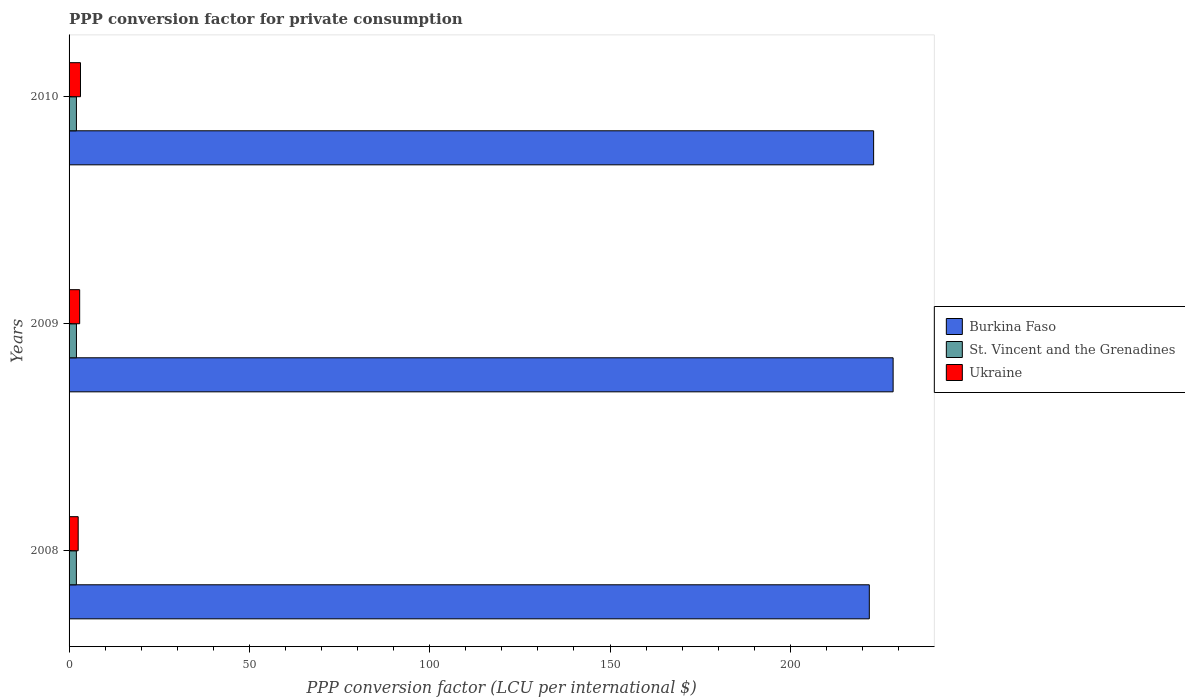How many different coloured bars are there?
Ensure brevity in your answer.  3. How many groups of bars are there?
Offer a terse response. 3. How many bars are there on the 3rd tick from the top?
Make the answer very short. 3. How many bars are there on the 2nd tick from the bottom?
Provide a succinct answer. 3. What is the PPP conversion factor for private consumption in St. Vincent and the Grenadines in 2009?
Offer a very short reply. 2.04. Across all years, what is the maximum PPP conversion factor for private consumption in St. Vincent and the Grenadines?
Give a very brief answer. 2.04. Across all years, what is the minimum PPP conversion factor for private consumption in Ukraine?
Your response must be concise. 2.53. What is the total PPP conversion factor for private consumption in St. Vincent and the Grenadines in the graph?
Your answer should be compact. 6.11. What is the difference between the PPP conversion factor for private consumption in St. Vincent and the Grenadines in 2008 and that in 2010?
Make the answer very short. -0.01. What is the difference between the PPP conversion factor for private consumption in Burkina Faso in 2009 and the PPP conversion factor for private consumption in St. Vincent and the Grenadines in 2008?
Provide a short and direct response. 226.48. What is the average PPP conversion factor for private consumption in St. Vincent and the Grenadines per year?
Keep it short and to the point. 2.04. In the year 2008, what is the difference between the PPP conversion factor for private consumption in St. Vincent and the Grenadines and PPP conversion factor for private consumption in Ukraine?
Give a very brief answer. -0.5. In how many years, is the PPP conversion factor for private consumption in St. Vincent and the Grenadines greater than 70 LCU?
Give a very brief answer. 0. What is the ratio of the PPP conversion factor for private consumption in Burkina Faso in 2008 to that in 2010?
Give a very brief answer. 0.99. Is the PPP conversion factor for private consumption in Burkina Faso in 2008 less than that in 2010?
Give a very brief answer. Yes. Is the difference between the PPP conversion factor for private consumption in St. Vincent and the Grenadines in 2008 and 2010 greater than the difference between the PPP conversion factor for private consumption in Ukraine in 2008 and 2010?
Offer a very short reply. Yes. What is the difference between the highest and the second highest PPP conversion factor for private consumption in St. Vincent and the Grenadines?
Make the answer very short. 0. What is the difference between the highest and the lowest PPP conversion factor for private consumption in Ukraine?
Your answer should be very brief. 0.64. In how many years, is the PPP conversion factor for private consumption in St. Vincent and the Grenadines greater than the average PPP conversion factor for private consumption in St. Vincent and the Grenadines taken over all years?
Your answer should be compact. 2. What does the 2nd bar from the top in 2010 represents?
Your response must be concise. St. Vincent and the Grenadines. What does the 3rd bar from the bottom in 2008 represents?
Your response must be concise. Ukraine. Are all the bars in the graph horizontal?
Offer a very short reply. Yes. How many years are there in the graph?
Your answer should be compact. 3. What is the difference between two consecutive major ticks on the X-axis?
Provide a succinct answer. 50. Does the graph contain any zero values?
Your answer should be very brief. No. Does the graph contain grids?
Offer a terse response. No. Where does the legend appear in the graph?
Your answer should be compact. Center right. What is the title of the graph?
Keep it short and to the point. PPP conversion factor for private consumption. What is the label or title of the X-axis?
Offer a terse response. PPP conversion factor (LCU per international $). What is the PPP conversion factor (LCU per international $) in Burkina Faso in 2008?
Ensure brevity in your answer.  221.91. What is the PPP conversion factor (LCU per international $) in St. Vincent and the Grenadines in 2008?
Ensure brevity in your answer.  2.03. What is the PPP conversion factor (LCU per international $) in Ukraine in 2008?
Offer a terse response. 2.53. What is the PPP conversion factor (LCU per international $) of Burkina Faso in 2009?
Give a very brief answer. 228.51. What is the PPP conversion factor (LCU per international $) in St. Vincent and the Grenadines in 2009?
Ensure brevity in your answer.  2.04. What is the PPP conversion factor (LCU per international $) in Ukraine in 2009?
Make the answer very short. 2.94. What is the PPP conversion factor (LCU per international $) in Burkina Faso in 2010?
Provide a succinct answer. 223.1. What is the PPP conversion factor (LCU per international $) in St. Vincent and the Grenadines in 2010?
Offer a terse response. 2.04. What is the PPP conversion factor (LCU per international $) in Ukraine in 2010?
Your response must be concise. 3.16. Across all years, what is the maximum PPP conversion factor (LCU per international $) of Burkina Faso?
Make the answer very short. 228.51. Across all years, what is the maximum PPP conversion factor (LCU per international $) of St. Vincent and the Grenadines?
Offer a very short reply. 2.04. Across all years, what is the maximum PPP conversion factor (LCU per international $) of Ukraine?
Your answer should be compact. 3.16. Across all years, what is the minimum PPP conversion factor (LCU per international $) of Burkina Faso?
Provide a succinct answer. 221.91. Across all years, what is the minimum PPP conversion factor (LCU per international $) in St. Vincent and the Grenadines?
Your answer should be very brief. 2.03. Across all years, what is the minimum PPP conversion factor (LCU per international $) of Ukraine?
Provide a succinct answer. 2.53. What is the total PPP conversion factor (LCU per international $) in Burkina Faso in the graph?
Offer a very short reply. 673.51. What is the total PPP conversion factor (LCU per international $) of St. Vincent and the Grenadines in the graph?
Make the answer very short. 6.11. What is the total PPP conversion factor (LCU per international $) in Ukraine in the graph?
Provide a succinct answer. 8.63. What is the difference between the PPP conversion factor (LCU per international $) of Burkina Faso in 2008 and that in 2009?
Provide a short and direct response. -6.6. What is the difference between the PPP conversion factor (LCU per international $) in St. Vincent and the Grenadines in 2008 and that in 2009?
Provide a short and direct response. -0.02. What is the difference between the PPP conversion factor (LCU per international $) of Ukraine in 2008 and that in 2009?
Give a very brief answer. -0.41. What is the difference between the PPP conversion factor (LCU per international $) in Burkina Faso in 2008 and that in 2010?
Your response must be concise. -1.19. What is the difference between the PPP conversion factor (LCU per international $) in St. Vincent and the Grenadines in 2008 and that in 2010?
Offer a terse response. -0.01. What is the difference between the PPP conversion factor (LCU per international $) in Ukraine in 2008 and that in 2010?
Keep it short and to the point. -0.64. What is the difference between the PPP conversion factor (LCU per international $) in Burkina Faso in 2009 and that in 2010?
Make the answer very short. 5.41. What is the difference between the PPP conversion factor (LCU per international $) of St. Vincent and the Grenadines in 2009 and that in 2010?
Ensure brevity in your answer.  0. What is the difference between the PPP conversion factor (LCU per international $) of Ukraine in 2009 and that in 2010?
Your answer should be compact. -0.22. What is the difference between the PPP conversion factor (LCU per international $) in Burkina Faso in 2008 and the PPP conversion factor (LCU per international $) in St. Vincent and the Grenadines in 2009?
Give a very brief answer. 219.86. What is the difference between the PPP conversion factor (LCU per international $) in Burkina Faso in 2008 and the PPP conversion factor (LCU per international $) in Ukraine in 2009?
Your response must be concise. 218.97. What is the difference between the PPP conversion factor (LCU per international $) of St. Vincent and the Grenadines in 2008 and the PPP conversion factor (LCU per international $) of Ukraine in 2009?
Your response must be concise. -0.91. What is the difference between the PPP conversion factor (LCU per international $) in Burkina Faso in 2008 and the PPP conversion factor (LCU per international $) in St. Vincent and the Grenadines in 2010?
Provide a short and direct response. 219.87. What is the difference between the PPP conversion factor (LCU per international $) of Burkina Faso in 2008 and the PPP conversion factor (LCU per international $) of Ukraine in 2010?
Offer a terse response. 218.74. What is the difference between the PPP conversion factor (LCU per international $) of St. Vincent and the Grenadines in 2008 and the PPP conversion factor (LCU per international $) of Ukraine in 2010?
Provide a succinct answer. -1.14. What is the difference between the PPP conversion factor (LCU per international $) in Burkina Faso in 2009 and the PPP conversion factor (LCU per international $) in St. Vincent and the Grenadines in 2010?
Give a very brief answer. 226.47. What is the difference between the PPP conversion factor (LCU per international $) in Burkina Faso in 2009 and the PPP conversion factor (LCU per international $) in Ukraine in 2010?
Provide a short and direct response. 225.34. What is the difference between the PPP conversion factor (LCU per international $) of St. Vincent and the Grenadines in 2009 and the PPP conversion factor (LCU per international $) of Ukraine in 2010?
Provide a short and direct response. -1.12. What is the average PPP conversion factor (LCU per international $) in Burkina Faso per year?
Offer a very short reply. 224.5. What is the average PPP conversion factor (LCU per international $) in St. Vincent and the Grenadines per year?
Offer a very short reply. 2.04. What is the average PPP conversion factor (LCU per international $) in Ukraine per year?
Give a very brief answer. 2.88. In the year 2008, what is the difference between the PPP conversion factor (LCU per international $) in Burkina Faso and PPP conversion factor (LCU per international $) in St. Vincent and the Grenadines?
Your answer should be compact. 219.88. In the year 2008, what is the difference between the PPP conversion factor (LCU per international $) of Burkina Faso and PPP conversion factor (LCU per international $) of Ukraine?
Your response must be concise. 219.38. In the year 2008, what is the difference between the PPP conversion factor (LCU per international $) in St. Vincent and the Grenadines and PPP conversion factor (LCU per international $) in Ukraine?
Your response must be concise. -0.5. In the year 2009, what is the difference between the PPP conversion factor (LCU per international $) in Burkina Faso and PPP conversion factor (LCU per international $) in St. Vincent and the Grenadines?
Ensure brevity in your answer.  226.46. In the year 2009, what is the difference between the PPP conversion factor (LCU per international $) in Burkina Faso and PPP conversion factor (LCU per international $) in Ukraine?
Your response must be concise. 225.57. In the year 2009, what is the difference between the PPP conversion factor (LCU per international $) of St. Vincent and the Grenadines and PPP conversion factor (LCU per international $) of Ukraine?
Make the answer very short. -0.9. In the year 2010, what is the difference between the PPP conversion factor (LCU per international $) of Burkina Faso and PPP conversion factor (LCU per international $) of St. Vincent and the Grenadines?
Your answer should be very brief. 221.06. In the year 2010, what is the difference between the PPP conversion factor (LCU per international $) of Burkina Faso and PPP conversion factor (LCU per international $) of Ukraine?
Offer a terse response. 219.94. In the year 2010, what is the difference between the PPP conversion factor (LCU per international $) of St. Vincent and the Grenadines and PPP conversion factor (LCU per international $) of Ukraine?
Provide a short and direct response. -1.13. What is the ratio of the PPP conversion factor (LCU per international $) in Burkina Faso in 2008 to that in 2009?
Your response must be concise. 0.97. What is the ratio of the PPP conversion factor (LCU per international $) of Ukraine in 2008 to that in 2009?
Offer a very short reply. 0.86. What is the ratio of the PPP conversion factor (LCU per international $) of Burkina Faso in 2008 to that in 2010?
Offer a terse response. 0.99. What is the ratio of the PPP conversion factor (LCU per international $) of Ukraine in 2008 to that in 2010?
Your answer should be very brief. 0.8. What is the ratio of the PPP conversion factor (LCU per international $) in Burkina Faso in 2009 to that in 2010?
Make the answer very short. 1.02. What is the ratio of the PPP conversion factor (LCU per international $) of St. Vincent and the Grenadines in 2009 to that in 2010?
Ensure brevity in your answer.  1. What is the ratio of the PPP conversion factor (LCU per international $) of Ukraine in 2009 to that in 2010?
Your response must be concise. 0.93. What is the difference between the highest and the second highest PPP conversion factor (LCU per international $) of Burkina Faso?
Your response must be concise. 5.41. What is the difference between the highest and the second highest PPP conversion factor (LCU per international $) of St. Vincent and the Grenadines?
Your response must be concise. 0. What is the difference between the highest and the second highest PPP conversion factor (LCU per international $) in Ukraine?
Your answer should be compact. 0.22. What is the difference between the highest and the lowest PPP conversion factor (LCU per international $) of Burkina Faso?
Give a very brief answer. 6.6. What is the difference between the highest and the lowest PPP conversion factor (LCU per international $) in St. Vincent and the Grenadines?
Your answer should be compact. 0.02. What is the difference between the highest and the lowest PPP conversion factor (LCU per international $) in Ukraine?
Your answer should be very brief. 0.64. 